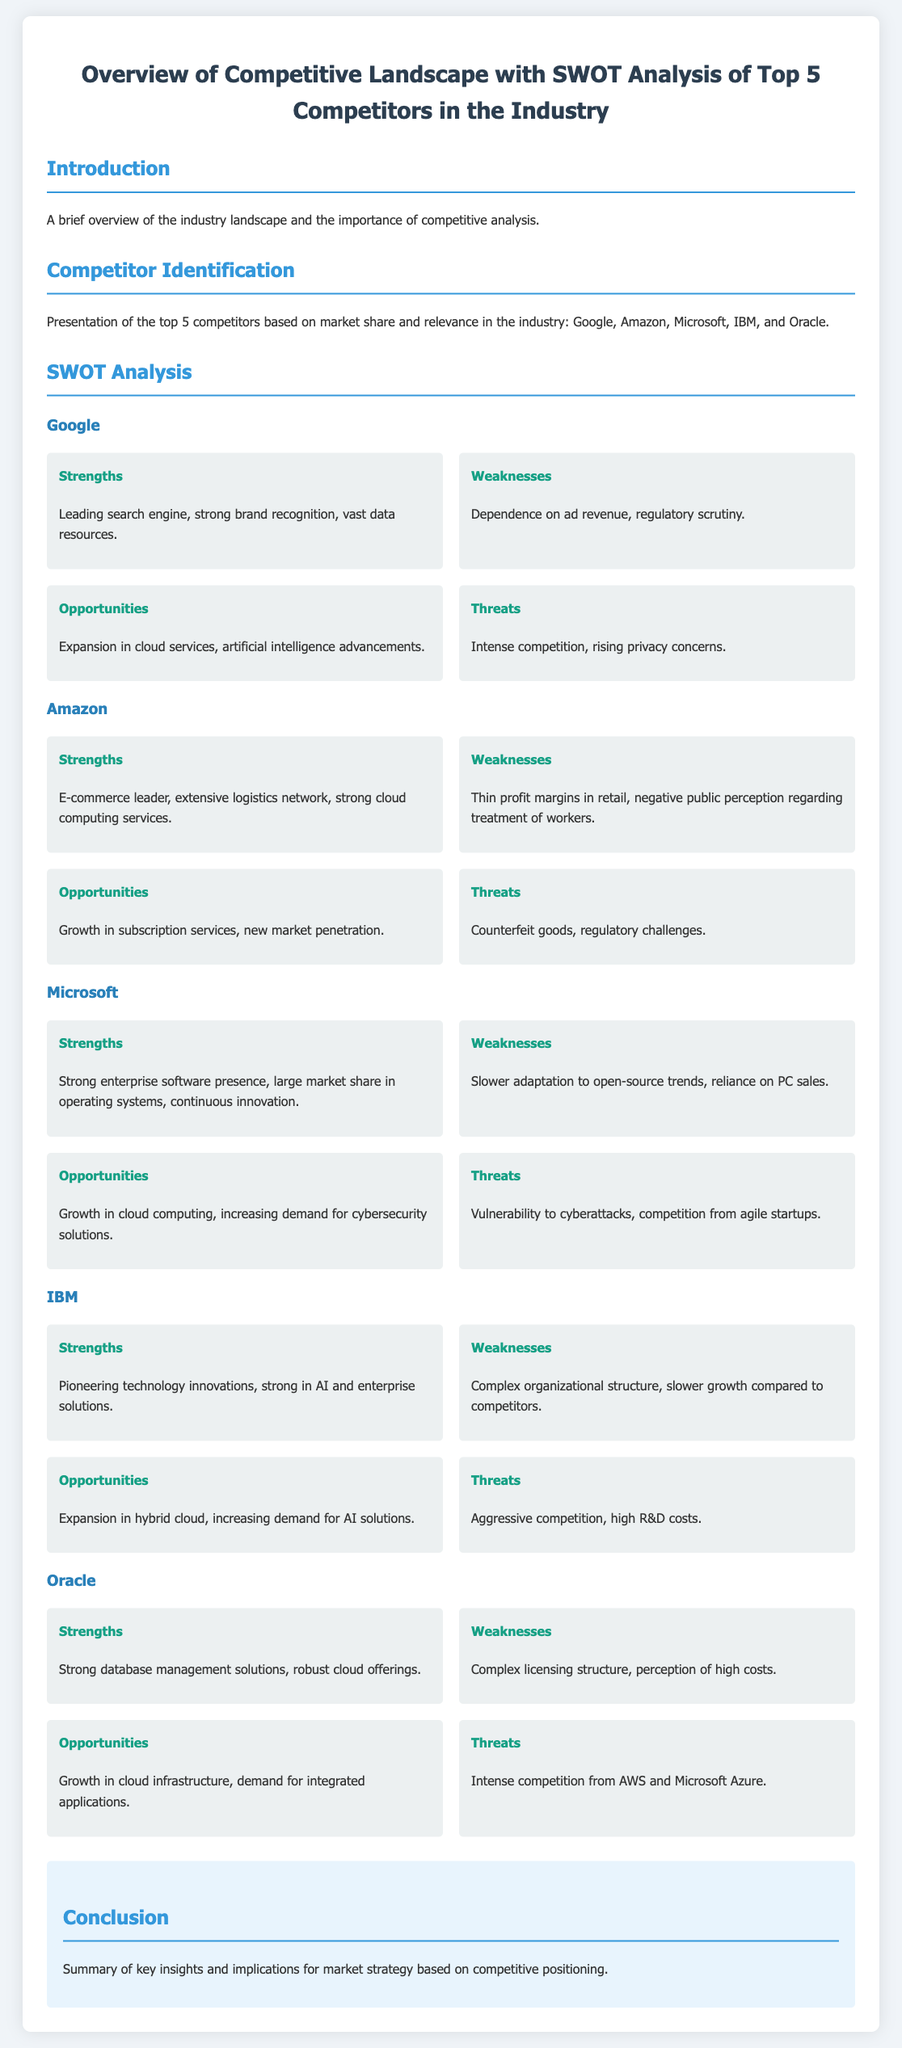What are the names of the top 5 competitors? The document presents Google, Amazon, Microsoft, IBM, and Oracle as the top competitors.
Answer: Google, Amazon, Microsoft, IBM, Oracle What is the main strength of Google? Google's leading search engine and strong brand recognition are highlighted as its main strengths.
Answer: Leading search engine, strong brand recognition What opportunity does Amazon have? The document states that Amazon has growth in subscription services as an opportunity.
Answer: Growth in subscription services Which competitor is known for its pioneering technology innovations? IBM is identified as the competitor known for its pioneering technology innovations.
Answer: IBM What is a key threat to Microsoft? Vulnerability to cyberattacks is noted as a key threat to Microsoft in the document.
Answer: Vulnerability to cyberattacks What weakness is associated with Oracle? The document points out that Oracle's complex licensing structure is a significant weakness.
Answer: Complex licensing structure Which company has the strongest presence in enterprise software? Microsoft is identified as having a strong presence in enterprise software.
Answer: Microsoft What opportunity does IBM aim to expand into? The document indicates IBM's opportunity for expansion in hybrid cloud.
Answer: Expansion in hybrid cloud What summary is provided in the conclusion? The conclusion summarizes key insights and implications for market strategy based on competitive positioning.
Answer: Key insights and implications for market strategy 